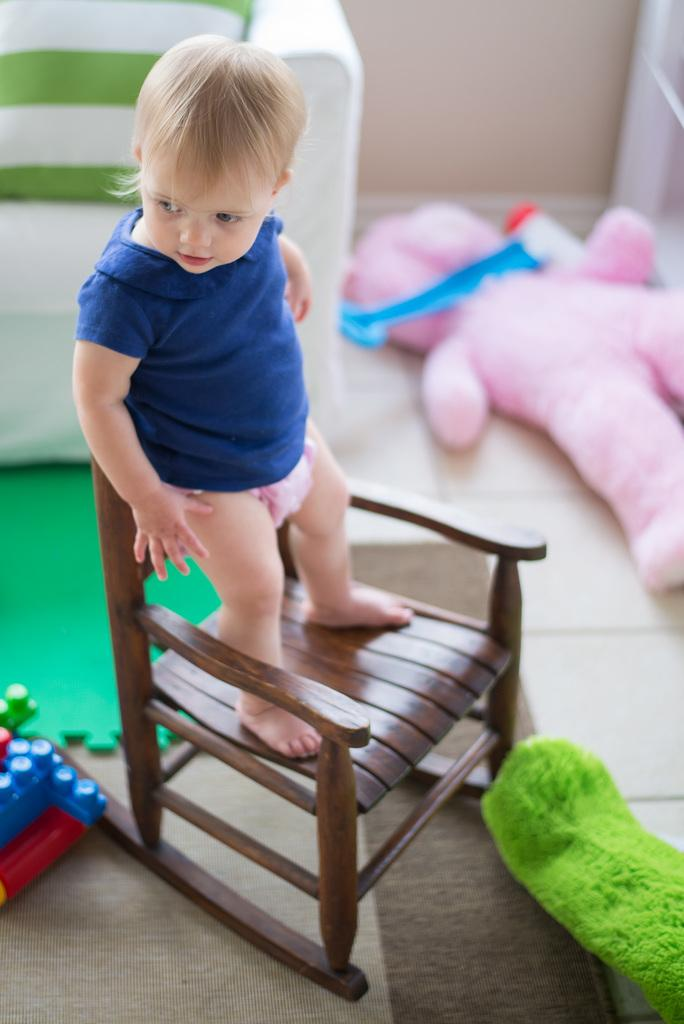What is the main subject of the image? There is a child in the image. What is the child doing in the image? The child is standing on a chair. What is the child wearing in the image? The child is wearing a blue color top. What can be seen on the floor in the image? There is a doll on the floor and other objects on the floor. What type of metal is the child using to invent a new toy in the image? There is no metal or invention present in the image; the child is simply standing on a chair and wearing a blue top. 